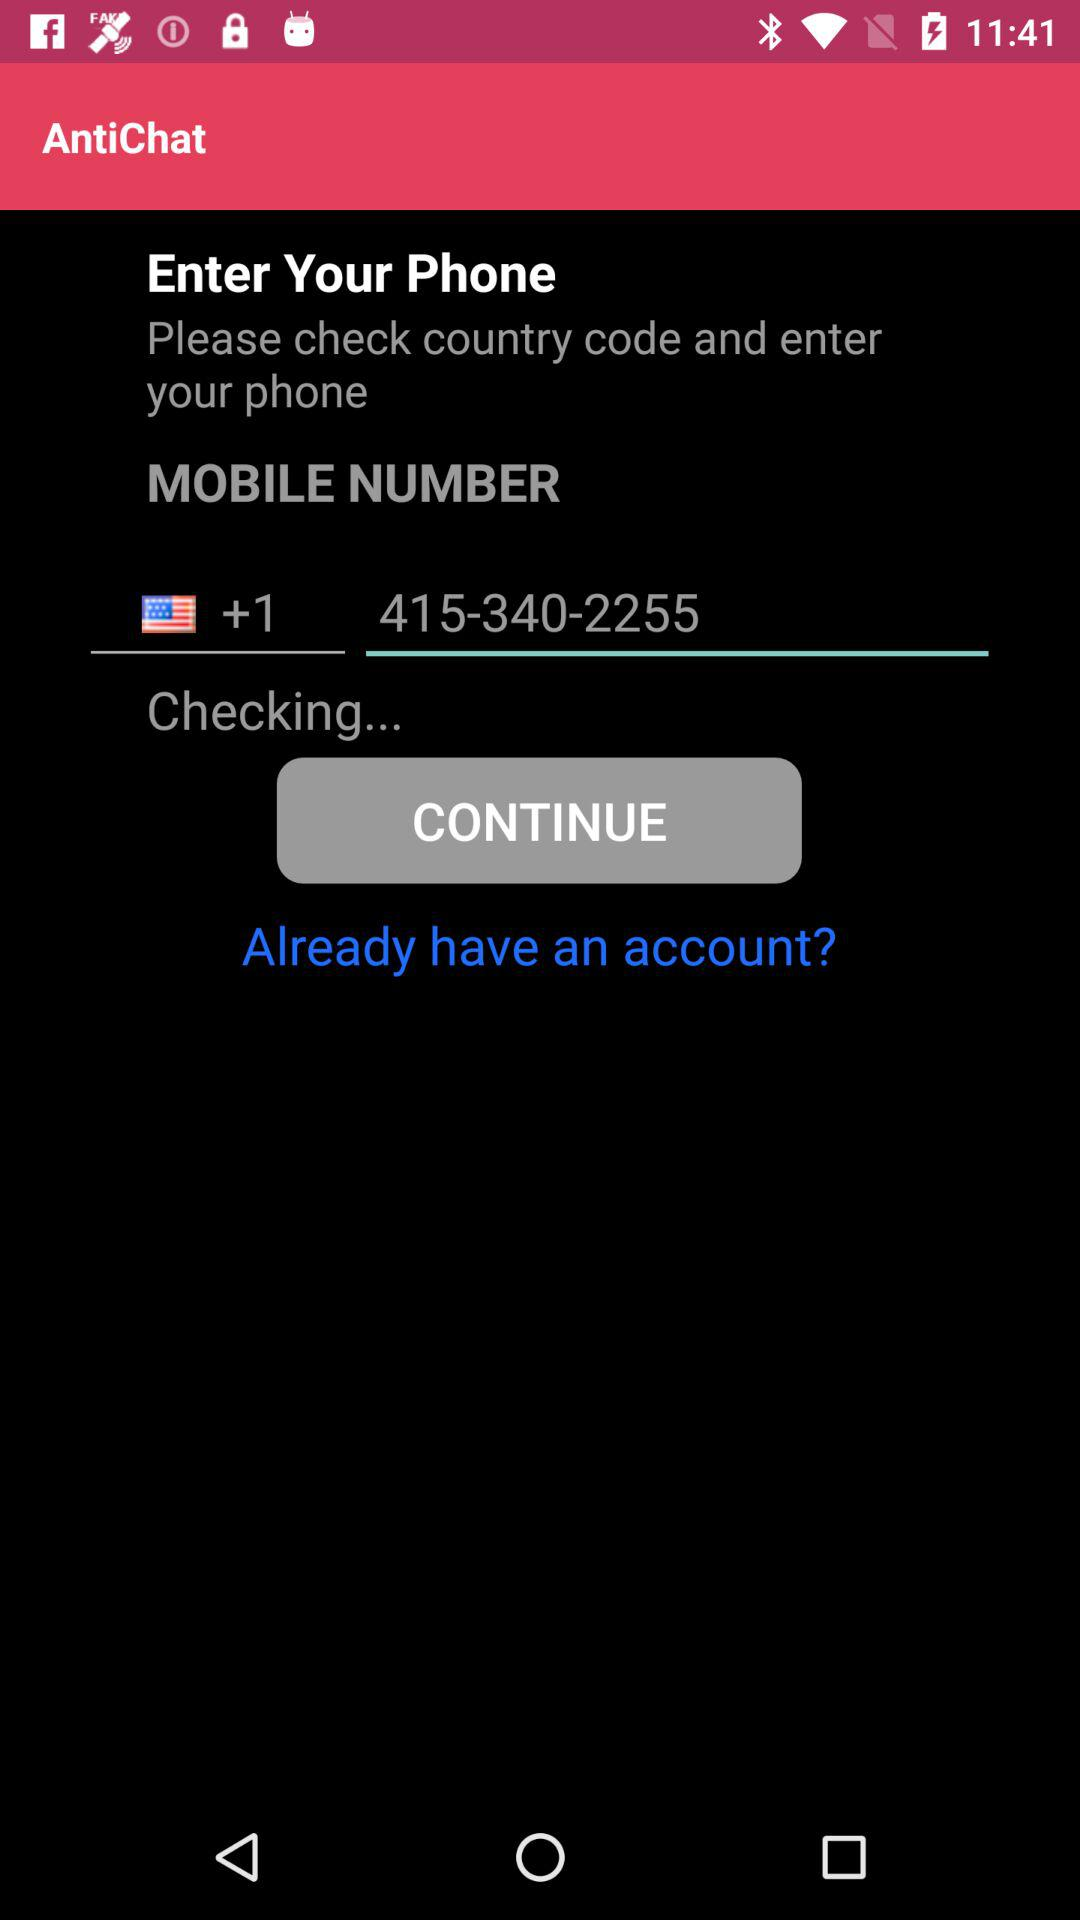What is the phone number given? The given phone number is 415-340-2255. 